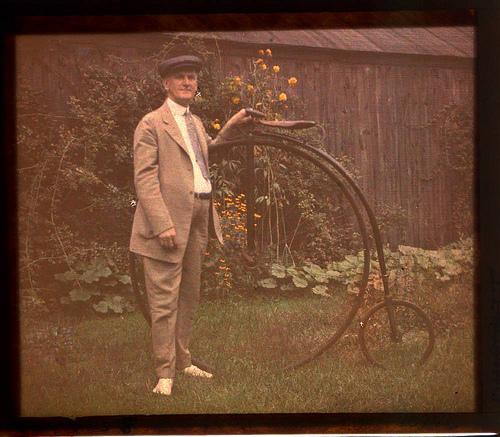What decade does this appear to be?
Keep it brief. 1920. Is this a normal bicycle?
Short answer required. No. What fruit is most prominently featured here?
Answer briefly. Oranges. How do you get on this cycle?
Be succinct. Ladder. 